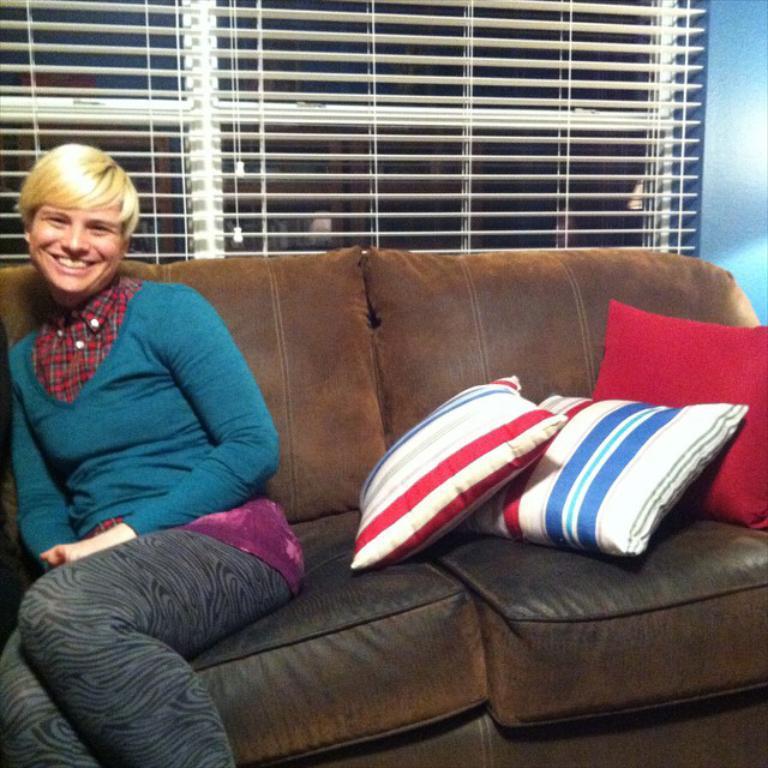In one or two sentences, can you explain what this image depicts? In this image i can see a woman sitting on a couch, I can see 3 pillows on the couch. In the background i can see a window and a window blind. 